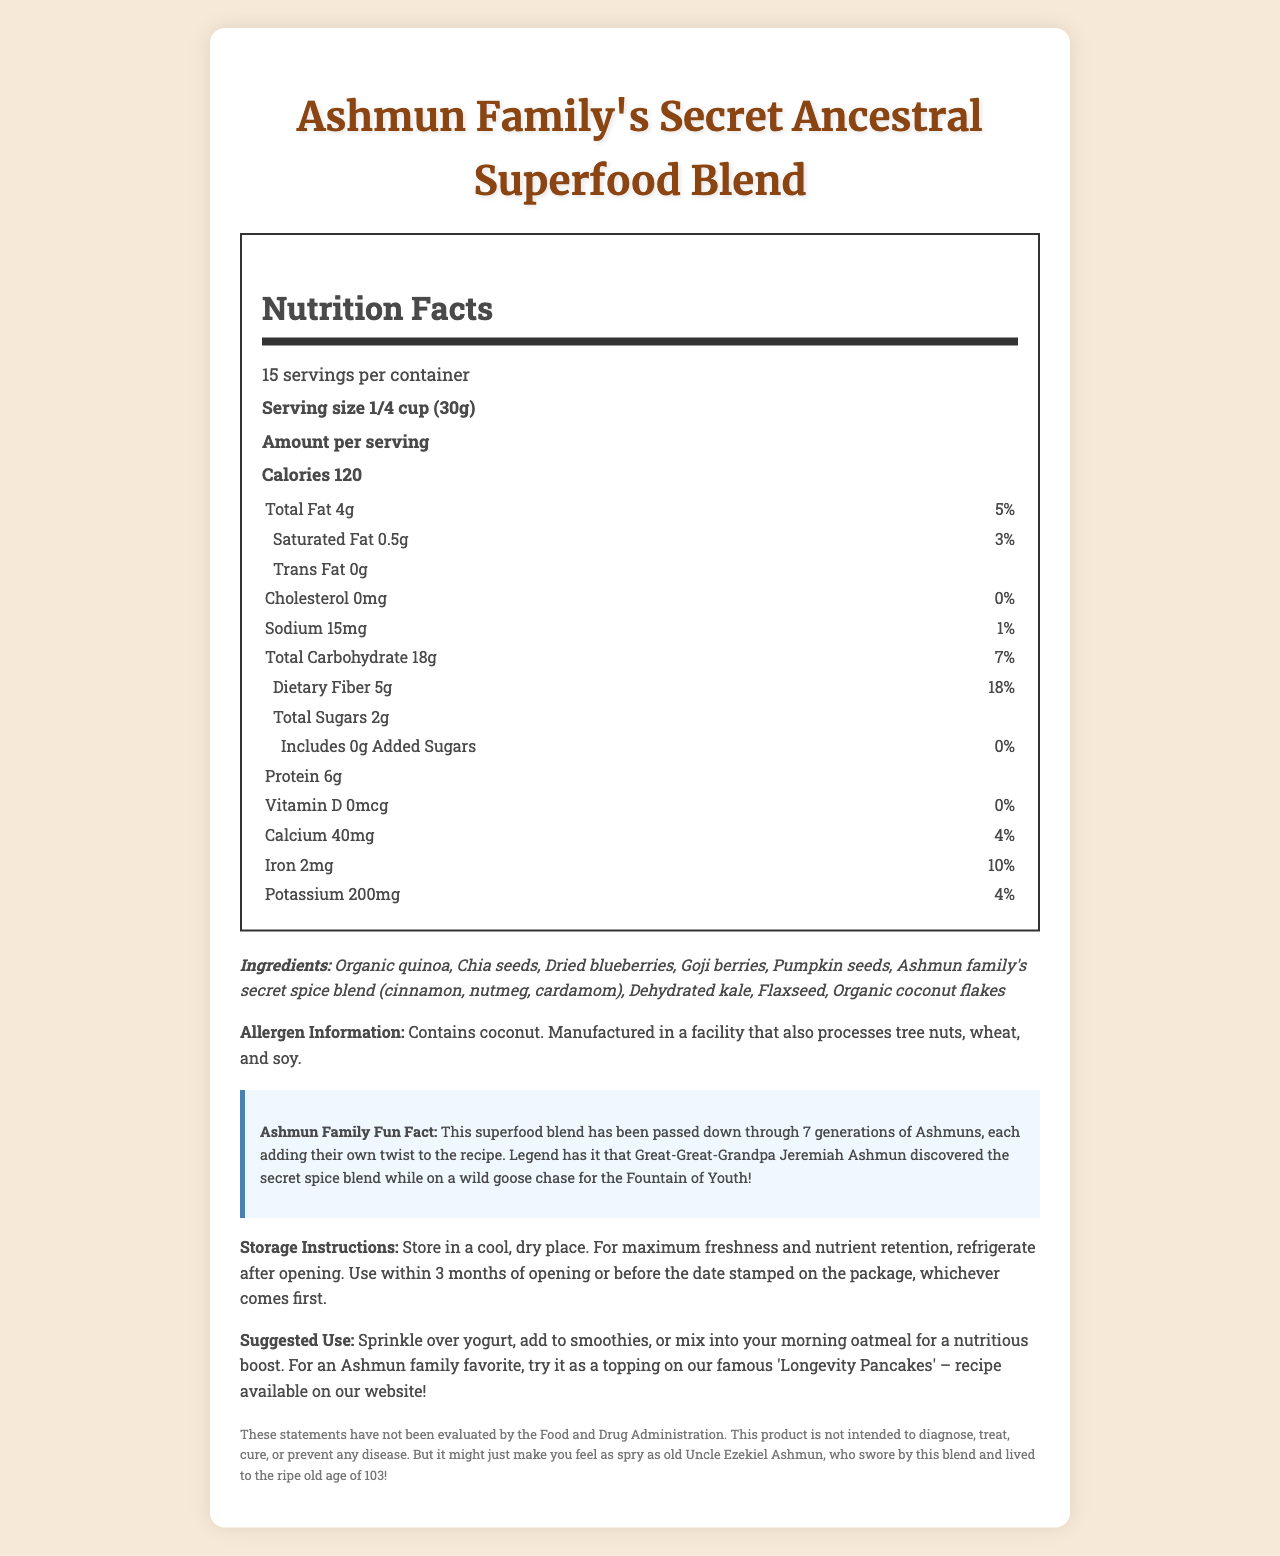what is the serving size? The serving size is explicitly mentioned as "1/4 cup (30g)" in the nutrition facts section.
Answer: 1/4 cup (30g) how many calories are there per serving? The document lists that there are 120 calories per serving.
Answer: 120 what kind of fats are present in the blend, and in what amount? The document provides detailed information about the types of fats and their amounts: Total Fat is 4g, Saturated Fat is 0.5g, and there are 0g Trans Fat.
Answer: Total Fat: 4g, Saturated Fat: 0.5g, Trans Fat: 0g how much dietary fiber is in one serving of the blend? The document states that there are 5g of dietary fiber per serving.
Answer: 5g what are the main ingredients in the Ashmun Family's Secret Ancestral Superfood Blend? The ingredients are listed in the document and include mostly organic and nut-related items.
Answer: Organic quinoa, Chia seeds, Dried blueberries, Goji berries, Pumpkin seeds, Ashmun family's secret spice blend (cinnamon, nutmeg, cardamom), Dehydrated kale, Flaxseed, Organic coconut flakes is there any added sugar in the blend? The document specifies that there are 0g of added sugars in the blend.
Answer: No how much iron does one serving provide? The document lists that one serving contains 2mg of iron.
Answer: 2mg which family member is mentioned in the Ashmun Family Fun Fact? The Fun Fact section mentions Great-Great-Grandpa Jeremiah Ashmun and his discovery of the secret spice blend.
Answer: Great-Great-Grandpa Jeremiah Ashmun how many servings are there per container? A. 10 B. 15 C. 20 D. 25 The document states that there are 15 servings per container.
Answer: B. 15 what is the recommended storage method? A. Room temperature B. Cool, dry place C. Freezer D. Pantry The document advises storing the blend in a cool, dry place for maximum freshness and nutrient retention.
Answer: B. Cool, dry place can this blend be used as a topping on yogurt? The suggested use section mentions that the blend can be sprinkled over yogurt.
Answer: Yes does the blend contain any allergens? The document indicates that it contains coconut and mentions that it is manufactured in a facility that also processes tree nuts, wheat, and soy.
Answer: Yes summarize the main idea of this document. The document includes various sections such as nutrient details, fun facts related to Ashmun family history, storage and use recommendations, and a disclaimer.
Answer: The document provides detailed nutritional information, ingredients, allergen info, fun facts, storage instructions, and suggested uses for the Ashmun Family's Secret Ancestral Superfood Blend. It highlights the nutritional benefits and historical background of the blend. what is the total carbohydrate content per serving? The total carbohydrate content per serving is listed as 18g in the document.
Answer: 18g how many grams of protein are there per serving of the blend? The document states that each serving contains 6g of protein.
Answer: 6g how much Vitamin D is present in the blend? There is no Vitamin D (0mcg) present in the blend as per the document.
Answer: 0mcg who evaluated the statements regarding the health benefits of this product? The disclaimer section states that these statements have not been evaluated by the Food and Drug Administration, providing no further evaluative details.
Answer: Not enough information 